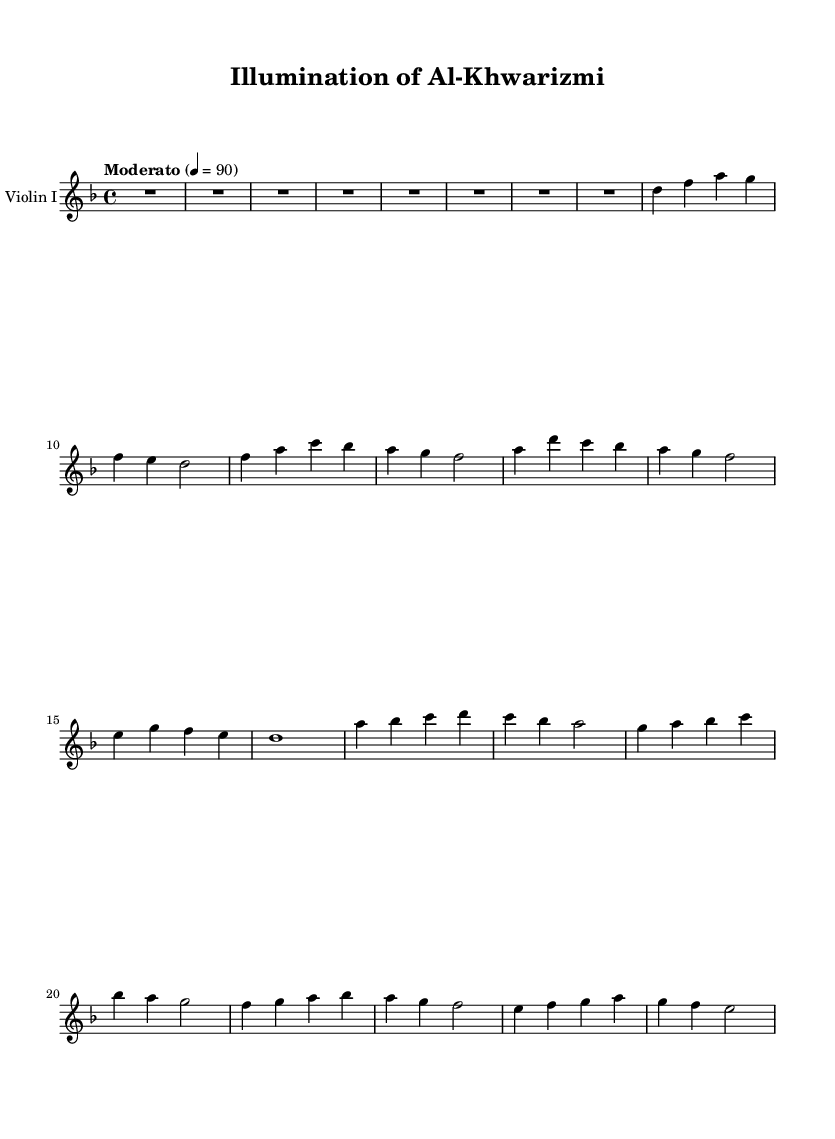What is the key signature of this music? The key signature is indicated by the number of sharps or flats at the beginning of the staff. In this case, there are no sharps or flats shown, indicating it is in D minor.
Answer: D minor What is the time signature of the piece? The time signature is located at the beginning of the staff and indicates the rhythmic structure of the music. Here, it is marked as 4/4, meaning there are four beats in each measure and the quarter note gets one beat.
Answer: 4/4 What is the tempo marking provided for this score? The tempo marking is typically found at the beginning of the score and indicates the speed of the music. In this score, the tempo is marked as "Moderato" with a metronome marking of 90 beats per minute.
Answer: Moderato, 90 How many bars make up the introduction? The introduction section is clearly delineated in the score and is labeled as having a total of 8 bars, which is counted based on the number of vertical lines indicating the end of each measure.
Answer: 8 bars What are the notes of Theme A in order? To find the notes, I will refer to the measures labeled as Theme A, which is indicated in the score. The notes in this theme are: D, F, A, G, F, E, D, F, A, C, B flat, A, G, F, A, D, C, B flat, A, G, F, E.
Answer: D, F, A, G, F, E, D, F, A, C, B flat, A, G, F, A, D, C, B flat, A, G, F, E What characterizes the role of violins in this soundtrack? Violins typically play the melody line and are essential for conveying emotional intensity in orchestral scores. In this specific piece, the Violin I has a leading melodic role in presenting Themes A and B, showcasing the development and interaction of musical ideas inspired by historical figures.
Answer: Leading melodic role 